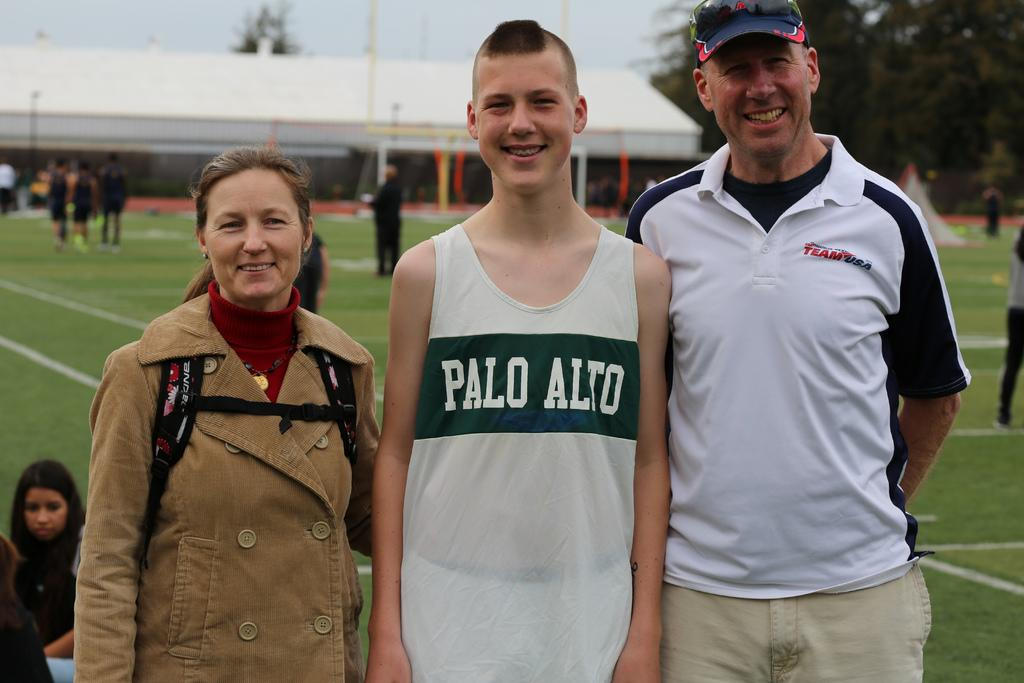<image>
Create a compact narrative representing the image presented. A boy wearing a Palo Alto sports tank top stands between his parents. 